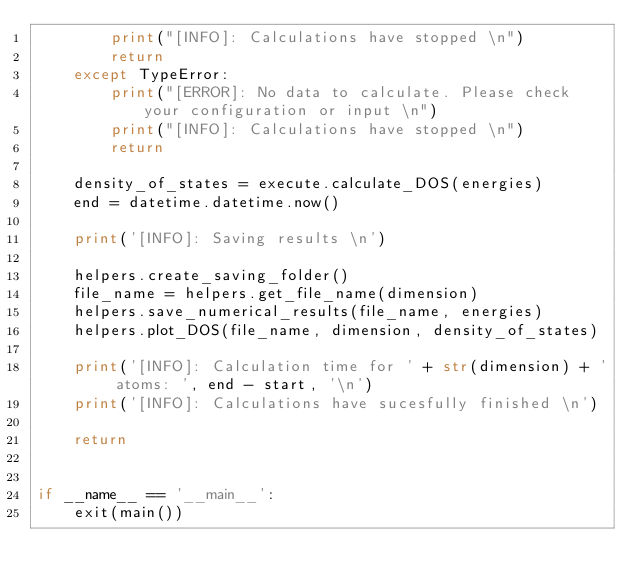<code> <loc_0><loc_0><loc_500><loc_500><_Python_>        print("[INFO]: Calculations have stopped \n")
        return
    except TypeError:
        print("[ERROR]: No data to calculate. Please check your configuration or input \n")
        print("[INFO]: Calculations have stopped \n")
        return

    density_of_states = execute.calculate_DOS(energies)
    end = datetime.datetime.now()

    print('[INFO]: Saving results \n')

    helpers.create_saving_folder()
    file_name = helpers.get_file_name(dimension)
    helpers.save_numerical_results(file_name, energies)
    helpers.plot_DOS(file_name, dimension, density_of_states)

    print('[INFO]: Calculation time for ' + str(dimension) + ' atoms: ', end - start, '\n')
    print('[INFO]: Calculations have sucesfully finished \n')

    return


if __name__ == '__main__':
    exit(main())
</code> 